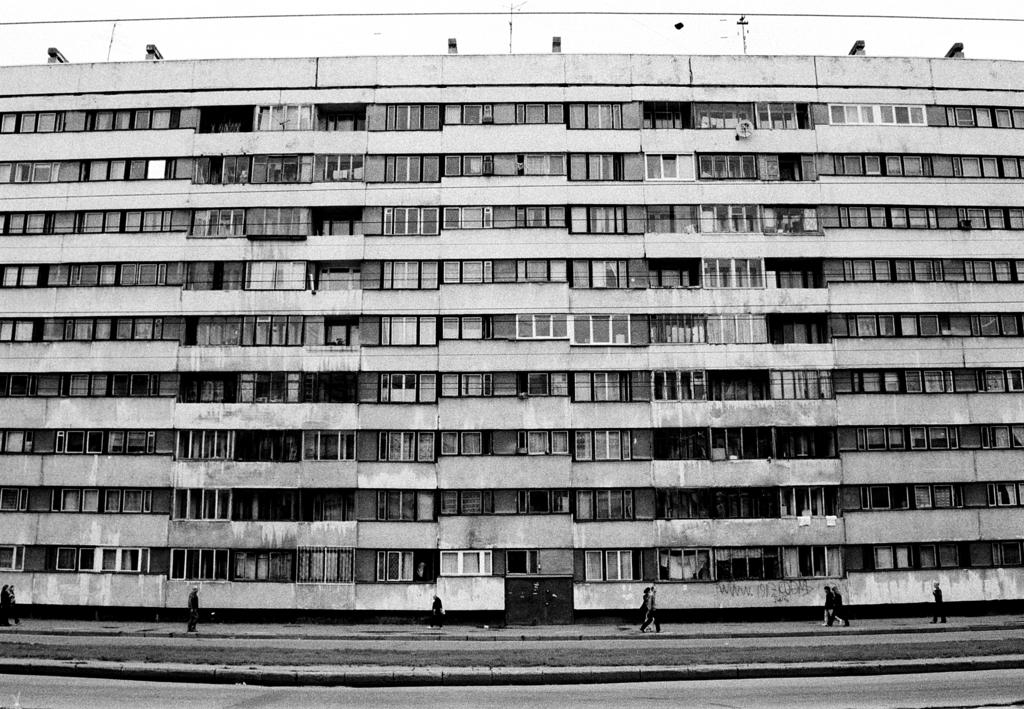What is the color scheme of the image? The image is black and white. What can be seen on the ground in the image? There is a group of people on the ground. What type of structure is present in the image? There is a building with windows in the image. What are the vertical structures visible in the image? There are poles visible in the image. What is visible above the ground in the image? The sky is visible in the image. What hobbies do the people in the image engage in with their combs? There is no mention of combs or any hobby-related activities in the image. 